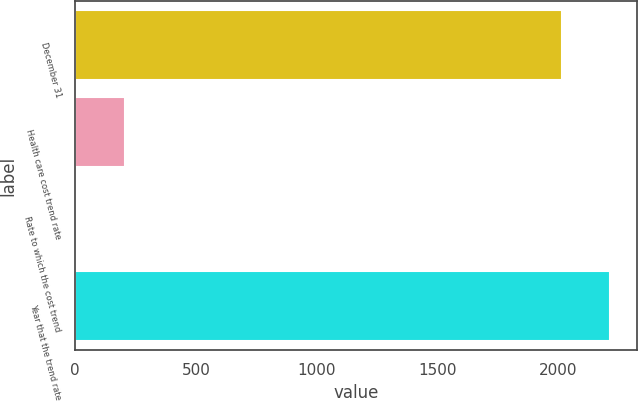Convert chart. <chart><loc_0><loc_0><loc_500><loc_500><bar_chart><fcel>December 31<fcel>Health care cost trend rate<fcel>Rate to which the cost trend<fcel>Year that the trend rate<nl><fcel>2015<fcel>206.75<fcel>4.5<fcel>2217.25<nl></chart> 